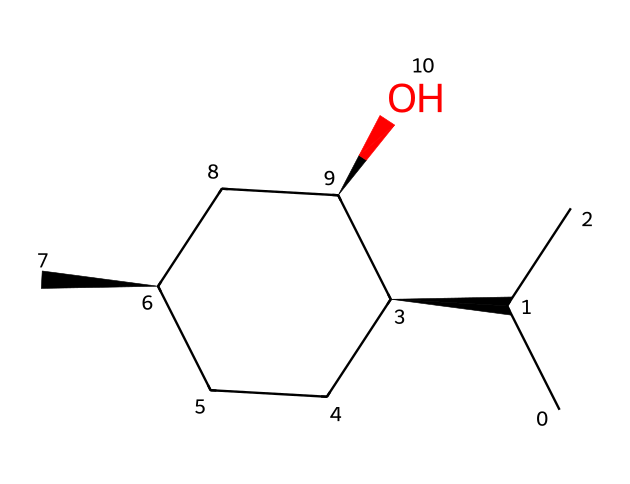What is the common name of this chiral compound? The SMILES representation corresponds to menthol, which is a well-known compound used for its cooling sensation and is often found in dental products. The specific arrangement of its carbon and hydroxyl group indicates it is menthol.
Answer: menthol How many chiral centers are present in this structure? By examining the structure, we identify the chiral centers, which are the carbon atoms bonded to four different substituents. There are three chiral centers in this molecule.
Answer: three What is the primary functional group in menthol? The SMILES indicates the presence of the -OH group, which characterizes alcohols. This functional group is the hydroxyl group connected to a carbon atom in the structure of menthol.
Answer: hydroxyl What type of stereochemistry is shown in this compound? The chirality is specified by the "@" symbols in the SMILES, indicating the stereocenters of the molecule. The presence of both clockwise and counterclockwise configurations suggests it has both R and S stereochemistry.
Answer: R and S What effect does menthol have when used in dental products? Menthol activates the cold-sensitive receptors in our mouth, leading to a cooling sensation. This property makes it effective for providing relief during dental procedures.
Answer: cooling sensation 